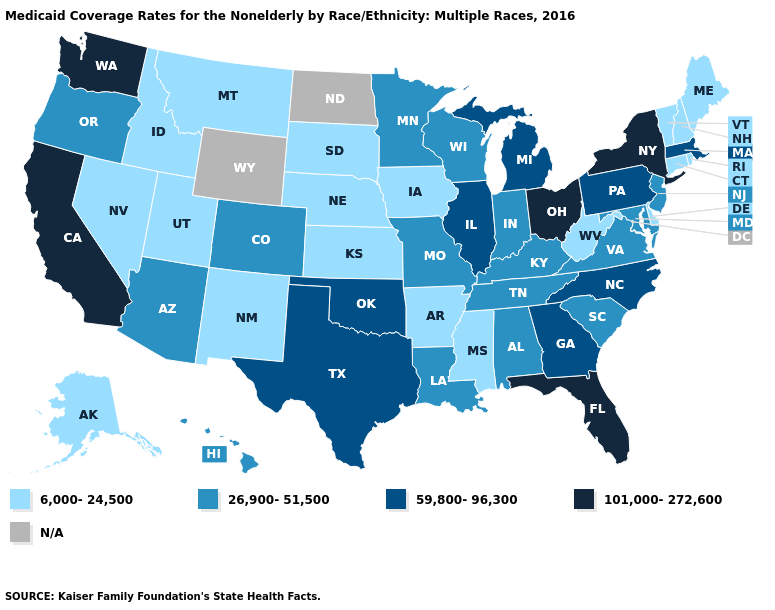Name the states that have a value in the range 101,000-272,600?
Concise answer only. California, Florida, New York, Ohio, Washington. What is the highest value in the Northeast ?
Write a very short answer. 101,000-272,600. What is the highest value in the Northeast ?
Keep it brief. 101,000-272,600. What is the highest value in the West ?
Keep it brief. 101,000-272,600. What is the value of Maine?
Answer briefly. 6,000-24,500. What is the value of North Carolina?
Answer briefly. 59,800-96,300. Does Vermont have the highest value in the Northeast?
Write a very short answer. No. What is the lowest value in states that border Nevada?
Short answer required. 6,000-24,500. Which states have the highest value in the USA?
Short answer required. California, Florida, New York, Ohio, Washington. What is the highest value in states that border Tennessee?
Quick response, please. 59,800-96,300. Name the states that have a value in the range 59,800-96,300?
Short answer required. Georgia, Illinois, Massachusetts, Michigan, North Carolina, Oklahoma, Pennsylvania, Texas. What is the value of New Hampshire?
Concise answer only. 6,000-24,500. Name the states that have a value in the range N/A?
Answer briefly. North Dakota, Wyoming. Name the states that have a value in the range 26,900-51,500?
Quick response, please. Alabama, Arizona, Colorado, Hawaii, Indiana, Kentucky, Louisiana, Maryland, Minnesota, Missouri, New Jersey, Oregon, South Carolina, Tennessee, Virginia, Wisconsin. 